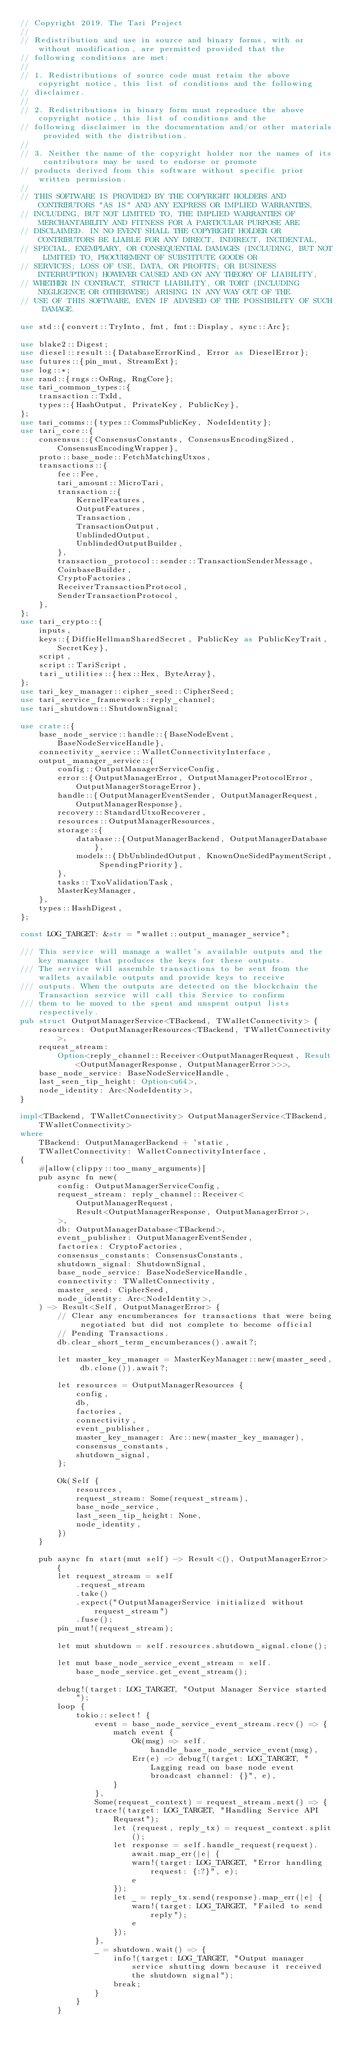Convert code to text. <code><loc_0><loc_0><loc_500><loc_500><_Rust_>// Copyright 2019. The Tari Project
//
// Redistribution and use in source and binary forms, with or without modification, are permitted provided that the
// following conditions are met:
//
// 1. Redistributions of source code must retain the above copyright notice, this list of conditions and the following
// disclaimer.
//
// 2. Redistributions in binary form must reproduce the above copyright notice, this list of conditions and the
// following disclaimer in the documentation and/or other materials provided with the distribution.
//
// 3. Neither the name of the copyright holder nor the names of its contributors may be used to endorse or promote
// products derived from this software without specific prior written permission.
//
// THIS SOFTWARE IS PROVIDED BY THE COPYRIGHT HOLDERS AND CONTRIBUTORS "AS IS" AND ANY EXPRESS OR IMPLIED WARRANTIES,
// INCLUDING, BUT NOT LIMITED TO, THE IMPLIED WARRANTIES OF MERCHANTABILITY AND FITNESS FOR A PARTICULAR PURPOSE ARE
// DISCLAIMED. IN NO EVENT SHALL THE COPYRIGHT HOLDER OR CONTRIBUTORS BE LIABLE FOR ANY DIRECT, INDIRECT, INCIDENTAL,
// SPECIAL, EXEMPLARY, OR CONSEQUENTIAL DAMAGES (INCLUDING, BUT NOT LIMITED TO, PROCUREMENT OF SUBSTITUTE GOODS OR
// SERVICES; LOSS OF USE, DATA, OR PROFITS; OR BUSINESS INTERRUPTION) HOWEVER CAUSED AND ON ANY THEORY OF LIABILITY,
// WHETHER IN CONTRACT, STRICT LIABILITY, OR TORT (INCLUDING NEGLIGENCE OR OTHERWISE) ARISING IN ANY WAY OUT OF THE
// USE OF THIS SOFTWARE, EVEN IF ADVISED OF THE POSSIBILITY OF SUCH DAMAGE.

use std::{convert::TryInto, fmt, fmt::Display, sync::Arc};

use blake2::Digest;
use diesel::result::{DatabaseErrorKind, Error as DieselError};
use futures::{pin_mut, StreamExt};
use log::*;
use rand::{rngs::OsRng, RngCore};
use tari_common_types::{
    transaction::TxId,
    types::{HashOutput, PrivateKey, PublicKey},
};
use tari_comms::{types::CommsPublicKey, NodeIdentity};
use tari_core::{
    consensus::{ConsensusConstants, ConsensusEncodingSized, ConsensusEncodingWrapper},
    proto::base_node::FetchMatchingUtxos,
    transactions::{
        fee::Fee,
        tari_amount::MicroTari,
        transaction::{
            KernelFeatures,
            OutputFeatures,
            Transaction,
            TransactionOutput,
            UnblindedOutput,
            UnblindedOutputBuilder,
        },
        transaction_protocol::sender::TransactionSenderMessage,
        CoinbaseBuilder,
        CryptoFactories,
        ReceiverTransactionProtocol,
        SenderTransactionProtocol,
    },
};
use tari_crypto::{
    inputs,
    keys::{DiffieHellmanSharedSecret, PublicKey as PublicKeyTrait, SecretKey},
    script,
    script::TariScript,
    tari_utilities::{hex::Hex, ByteArray},
};
use tari_key_manager::cipher_seed::CipherSeed;
use tari_service_framework::reply_channel;
use tari_shutdown::ShutdownSignal;

use crate::{
    base_node_service::handle::{BaseNodeEvent, BaseNodeServiceHandle},
    connectivity_service::WalletConnectivityInterface,
    output_manager_service::{
        config::OutputManagerServiceConfig,
        error::{OutputManagerError, OutputManagerProtocolError, OutputManagerStorageError},
        handle::{OutputManagerEventSender, OutputManagerRequest, OutputManagerResponse},
        recovery::StandardUtxoRecoverer,
        resources::OutputManagerResources,
        storage::{
            database::{OutputManagerBackend, OutputManagerDatabase},
            models::{DbUnblindedOutput, KnownOneSidedPaymentScript, SpendingPriority},
        },
        tasks::TxoValidationTask,
        MasterKeyManager,
    },
    types::HashDigest,
};

const LOG_TARGET: &str = "wallet::output_manager_service";

/// This service will manage a wallet's available outputs and the key manager that produces the keys for these outputs.
/// The service will assemble transactions to be sent from the wallets available outputs and provide keys to receive
/// outputs. When the outputs are detected on the blockchain the Transaction service will call this Service to confirm
/// them to be moved to the spent and unspent output lists respectively.
pub struct OutputManagerService<TBackend, TWalletConnectivity> {
    resources: OutputManagerResources<TBackend, TWalletConnectivity>,
    request_stream:
        Option<reply_channel::Receiver<OutputManagerRequest, Result<OutputManagerResponse, OutputManagerError>>>,
    base_node_service: BaseNodeServiceHandle,
    last_seen_tip_height: Option<u64>,
    node_identity: Arc<NodeIdentity>,
}

impl<TBackend, TWalletConnectivity> OutputManagerService<TBackend, TWalletConnectivity>
where
    TBackend: OutputManagerBackend + 'static,
    TWalletConnectivity: WalletConnectivityInterface,
{
    #[allow(clippy::too_many_arguments)]
    pub async fn new(
        config: OutputManagerServiceConfig,
        request_stream: reply_channel::Receiver<
            OutputManagerRequest,
            Result<OutputManagerResponse, OutputManagerError>,
        >,
        db: OutputManagerDatabase<TBackend>,
        event_publisher: OutputManagerEventSender,
        factories: CryptoFactories,
        consensus_constants: ConsensusConstants,
        shutdown_signal: ShutdownSignal,
        base_node_service: BaseNodeServiceHandle,
        connectivity: TWalletConnectivity,
        master_seed: CipherSeed,
        node_identity: Arc<NodeIdentity>,
    ) -> Result<Self, OutputManagerError> {
        // Clear any encumberances for transactions that were being negotiated but did not complete to become official
        // Pending Transactions.
        db.clear_short_term_encumberances().await?;

        let master_key_manager = MasterKeyManager::new(master_seed, db.clone()).await?;

        let resources = OutputManagerResources {
            config,
            db,
            factories,
            connectivity,
            event_publisher,
            master_key_manager: Arc::new(master_key_manager),
            consensus_constants,
            shutdown_signal,
        };

        Ok(Self {
            resources,
            request_stream: Some(request_stream),
            base_node_service,
            last_seen_tip_height: None,
            node_identity,
        })
    }

    pub async fn start(mut self) -> Result<(), OutputManagerError> {
        let request_stream = self
            .request_stream
            .take()
            .expect("OutputManagerService initialized without request_stream")
            .fuse();
        pin_mut!(request_stream);

        let mut shutdown = self.resources.shutdown_signal.clone();

        let mut base_node_service_event_stream = self.base_node_service.get_event_stream();

        debug!(target: LOG_TARGET, "Output Manager Service started");
        loop {
            tokio::select! {
                event = base_node_service_event_stream.recv() => {
                    match event {
                        Ok(msg) => self.handle_base_node_service_event(msg),
                        Err(e) => debug!(target: LOG_TARGET, "Lagging read on base node event broadcast channel: {}", e),
                    }
                },
                Some(request_context) = request_stream.next() => {
                trace!(target: LOG_TARGET, "Handling Service API Request");
                    let (request, reply_tx) = request_context.split();
                    let response = self.handle_request(request).await.map_err(|e| {
                        warn!(target: LOG_TARGET, "Error handling request: {:?}", e);
                        e
                    });
                    let _ = reply_tx.send(response).map_err(|e| {
                        warn!(target: LOG_TARGET, "Failed to send reply");
                        e
                    });
                },
                _ = shutdown.wait() => {
                    info!(target: LOG_TARGET, "Output manager service shutting down because it received the shutdown signal");
                    break;
                }
            }
        }</code> 